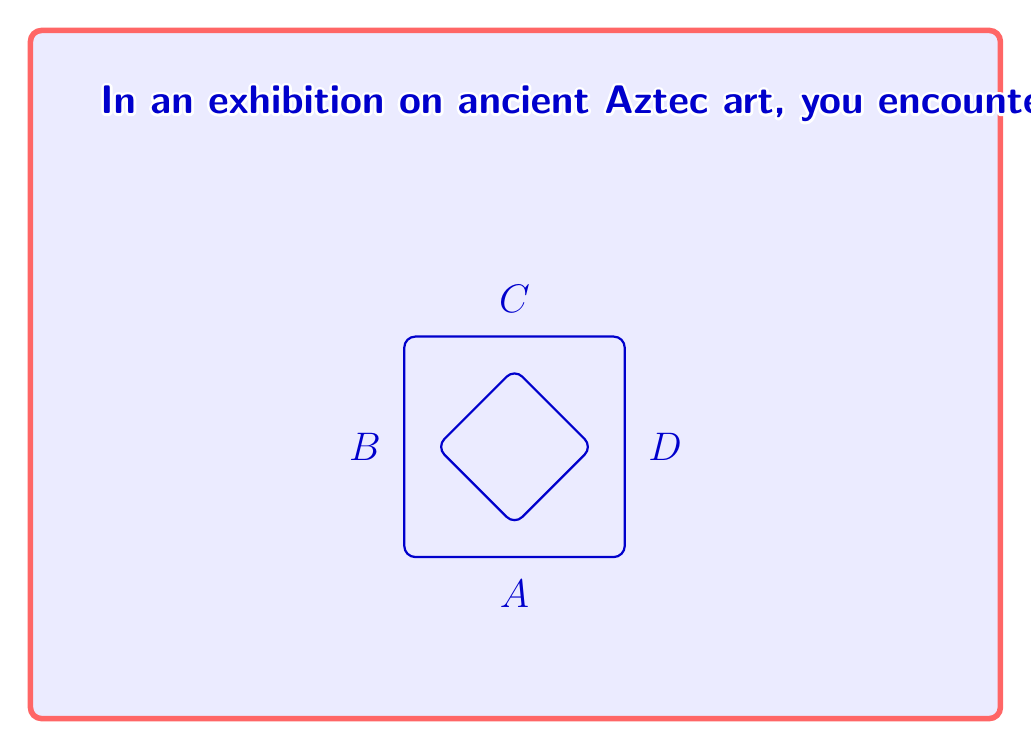Provide a solution to this math problem. Let's approach this step-by-step:

1) First, we need to represent the inner square's vertices as a 2x2 matrix A. Given that it's rotated 45 degrees, we can represent its vertices as:

   $$A = \begin{bmatrix} 
   0 & -1 & 0 & 1 \\
   -1 & 0 & 1 & 0
   \end{bmatrix}$$

   Where each column represents a vertex (A, B, C, D) in counterclockwise order.

2) The rotation matrix R for a 90-degree clockwise rotation is:

   $$R = \begin{bmatrix} 
   0 & 1 \\
   -1 & 0
   \end{bmatrix}$$

3) We need to verify if RA = A. Let's multiply R and A:

   $$RA = \begin{bmatrix} 
   0 & 1 \\
   -1 & 0
   \end{bmatrix} \begin{bmatrix} 
   0 & -1 & 0 & 1 \\
   -1 & 0 & 1 & 0
   \end{bmatrix}$$

4) Performing the matrix multiplication:

   $$RA = \begin{bmatrix} 
   -1 & 0 & 1 & 0 \\
   0 & 1 & 0 & -1
   \end{bmatrix}$$

5) We can see that RA = A, confirming that the pattern indeed has 90-degree rotational symmetry.

Therefore, the transformation matrix R that satisfies RA = A is:

$$R = \begin{bmatrix} 
0 & 1 \\
-1 & 0
\end{bmatrix}$$
Answer: $$\begin{bmatrix} 
0 & 1 \\
-1 & 0
\end{bmatrix}$$ 